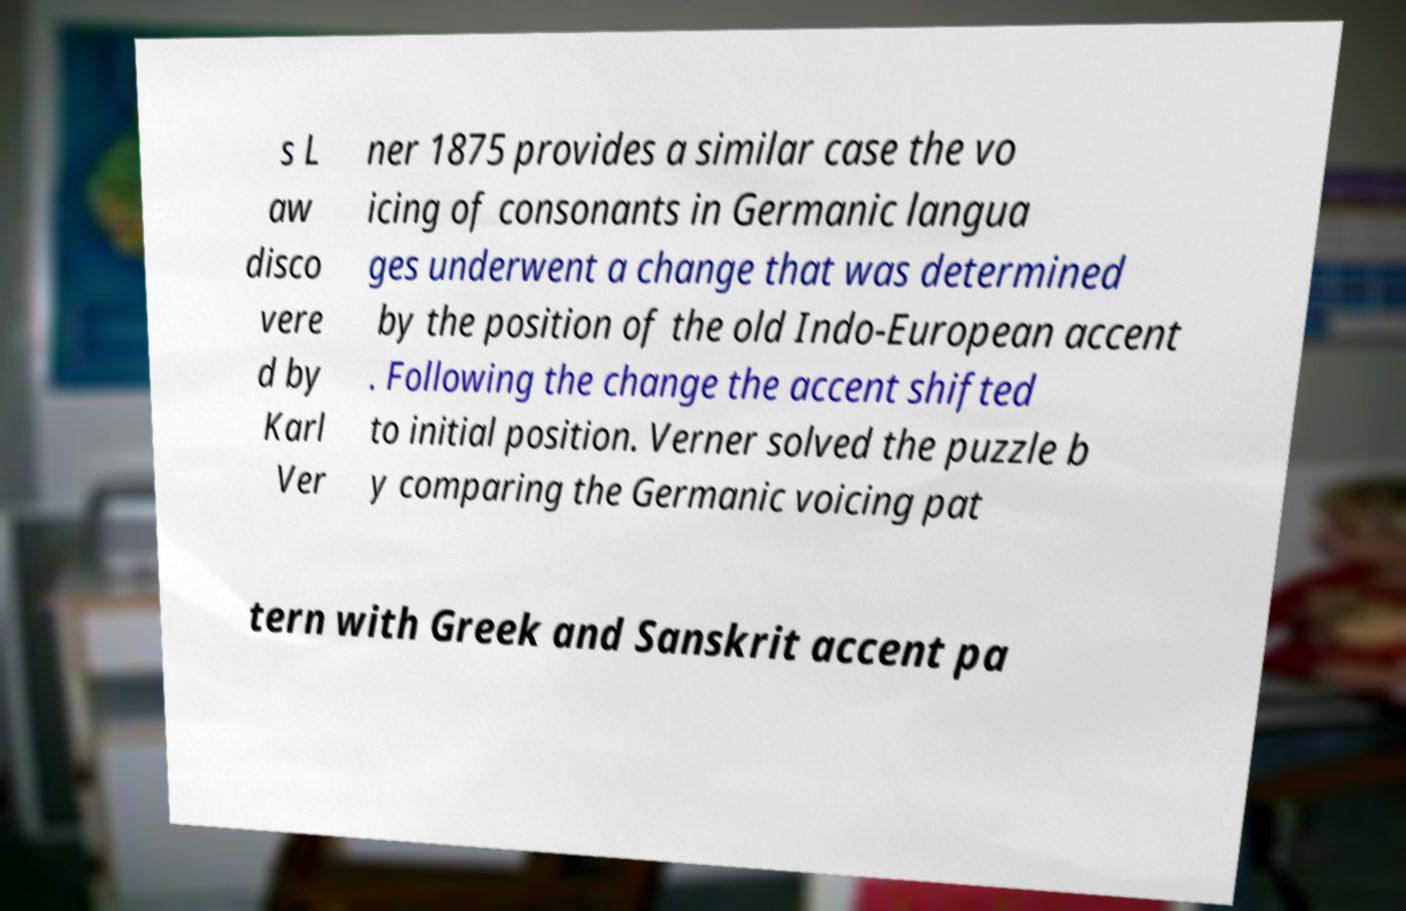What messages or text are displayed in this image? I need them in a readable, typed format. s L aw disco vere d by Karl Ver ner 1875 provides a similar case the vo icing of consonants in Germanic langua ges underwent a change that was determined by the position of the old Indo-European accent . Following the change the accent shifted to initial position. Verner solved the puzzle b y comparing the Germanic voicing pat tern with Greek and Sanskrit accent pa 